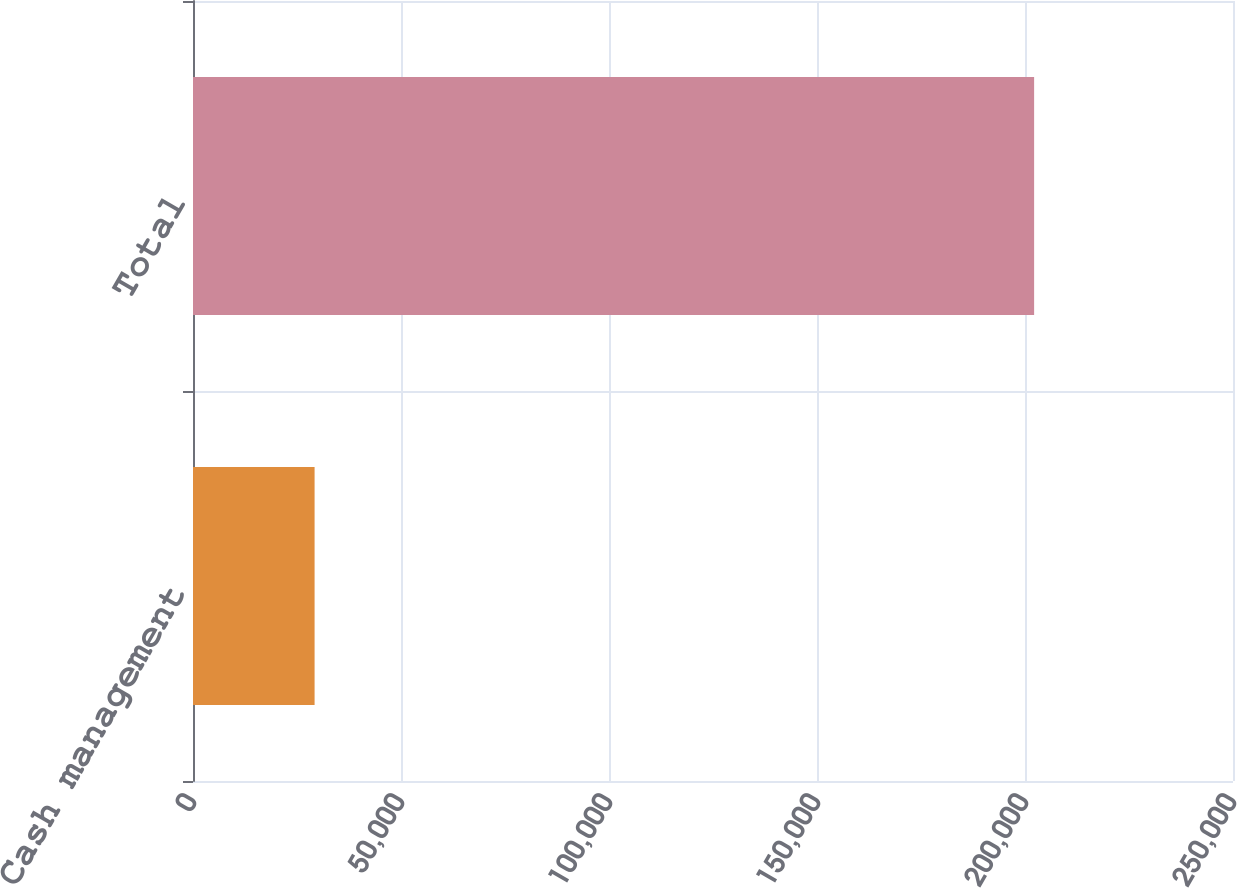<chart> <loc_0><loc_0><loc_500><loc_500><bar_chart><fcel>Cash management<fcel>Total<nl><fcel>29228<fcel>202191<nl></chart> 